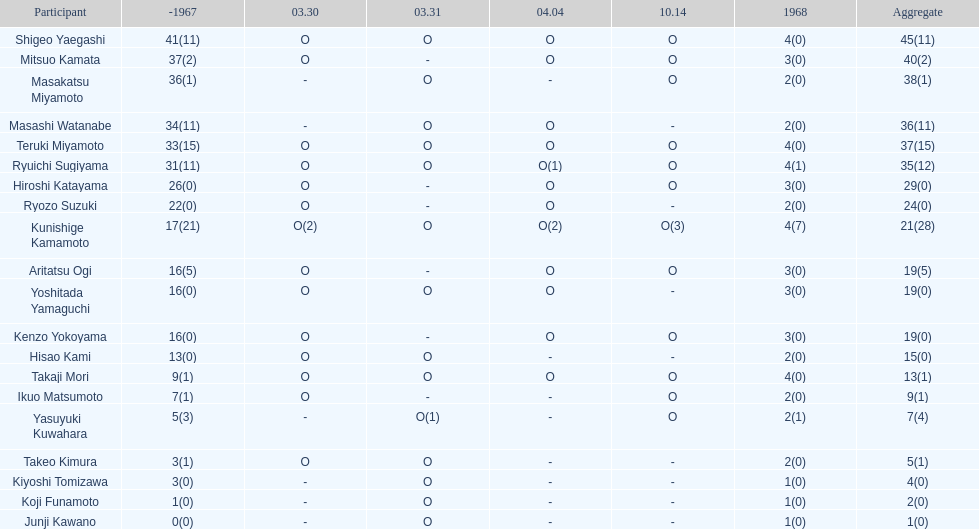Total appearances by masakatsu miyamoto? 38. 